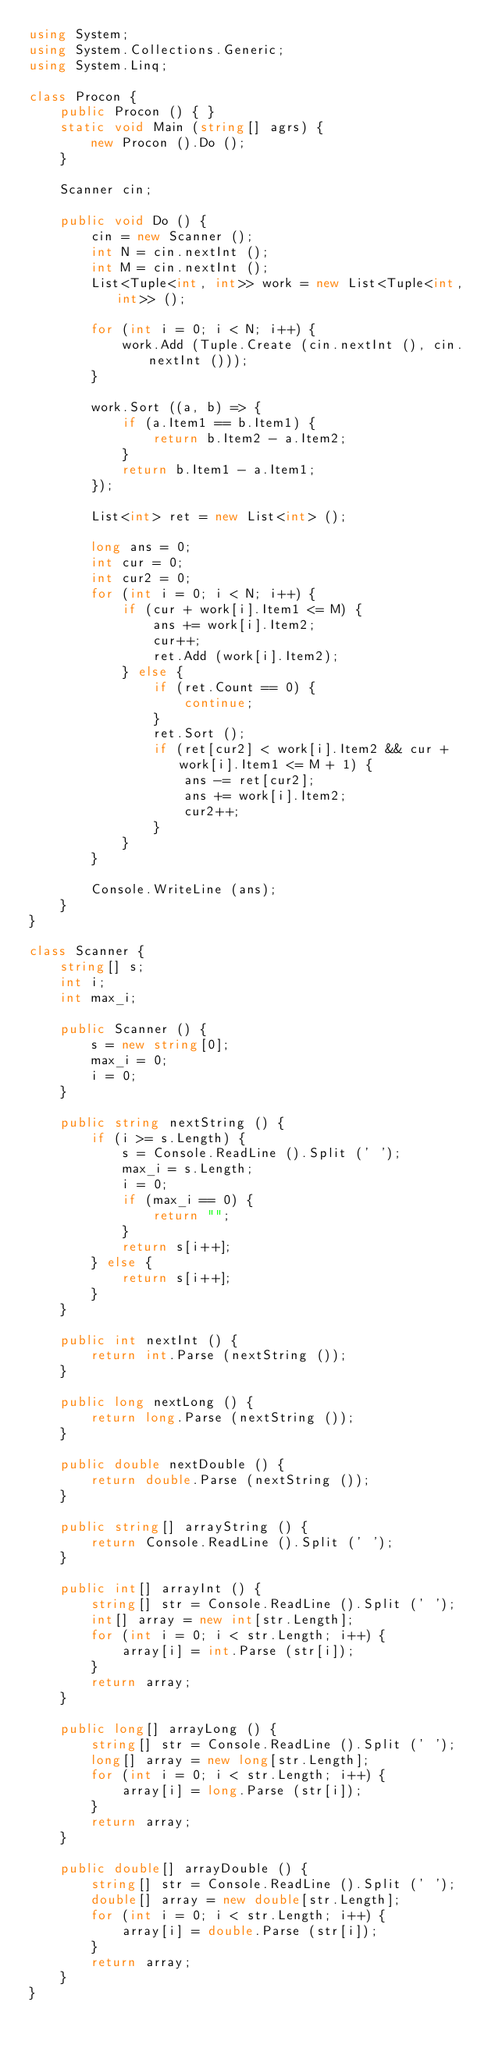<code> <loc_0><loc_0><loc_500><loc_500><_C#_>using System;
using System.Collections.Generic;
using System.Linq;

class Procon {
    public Procon () { }
    static void Main (string[] agrs) {
        new Procon ().Do ();
    }

    Scanner cin;

    public void Do () {
        cin = new Scanner ();
        int N = cin.nextInt ();
        int M = cin.nextInt ();
        List<Tuple<int, int>> work = new List<Tuple<int, int>> ();

        for (int i = 0; i < N; i++) {
            work.Add (Tuple.Create (cin.nextInt (), cin.nextInt ()));
        }

        work.Sort ((a, b) => {
            if (a.Item1 == b.Item1) {
                return b.Item2 - a.Item2;
            }
            return b.Item1 - a.Item1;
        });

        List<int> ret = new List<int> ();

        long ans = 0;
        int cur = 0;
        int cur2 = 0;
        for (int i = 0; i < N; i++) {
            if (cur + work[i].Item1 <= M) {
                ans += work[i].Item2;
                cur++;
                ret.Add (work[i].Item2);
            } else {
                if (ret.Count == 0) {
                    continue;
                }
                ret.Sort ();
                if (ret[cur2] < work[i].Item2 && cur + work[i].Item1 <= M + 1) {
                    ans -= ret[cur2];
                    ans += work[i].Item2;
                    cur2++;
                }
            }
        }

        Console.WriteLine (ans);
    }
}

class Scanner {
    string[] s;
    int i;
    int max_i;

    public Scanner () {
        s = new string[0];
        max_i = 0;
        i = 0;
    }

    public string nextString () {
        if (i >= s.Length) {
            s = Console.ReadLine ().Split (' ');
            max_i = s.Length;
            i = 0;
            if (max_i == 0) {
                return "";
            }
            return s[i++];
        } else {
            return s[i++];
        }
    }

    public int nextInt () {
        return int.Parse (nextString ());
    }

    public long nextLong () {
        return long.Parse (nextString ());
    }

    public double nextDouble () {
        return double.Parse (nextString ());
    }

    public string[] arrayString () {
        return Console.ReadLine ().Split (' ');
    }

    public int[] arrayInt () {
        string[] str = Console.ReadLine ().Split (' ');
        int[] array = new int[str.Length];
        for (int i = 0; i < str.Length; i++) {
            array[i] = int.Parse (str[i]);
        }
        return array;
    }

    public long[] arrayLong () {
        string[] str = Console.ReadLine ().Split (' ');
        long[] array = new long[str.Length];
        for (int i = 0; i < str.Length; i++) {
            array[i] = long.Parse (str[i]);
        }
        return array;
    }

    public double[] arrayDouble () {
        string[] str = Console.ReadLine ().Split (' ');
        double[] array = new double[str.Length];
        for (int i = 0; i < str.Length; i++) {
            array[i] = double.Parse (str[i]);
        }
        return array;
    }
}</code> 